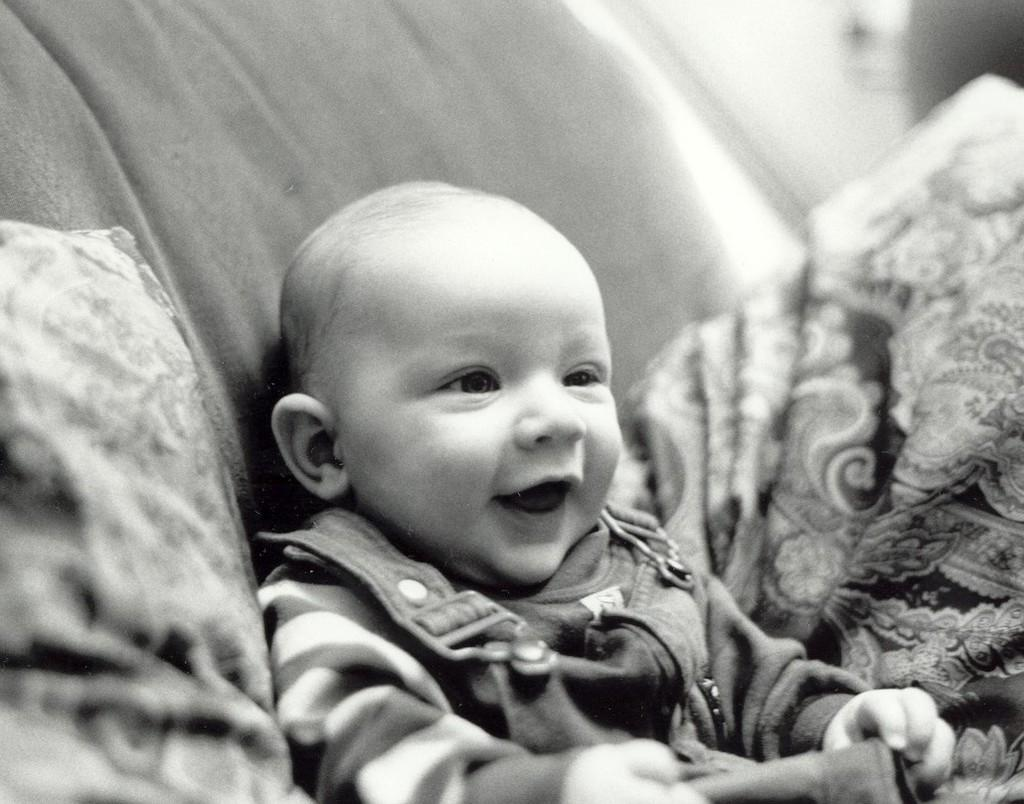What is the color scheme of the image? The image is black and white. Who or what is the main subject in the image? There is a kid in the image. Where is the kid located? The kid is on a sofa. What items can be seen on the sofa? There is a pillow and a bed sheet on the sofa. How would you describe the background of the image? The background of the image is blurry. What type of parcel is being delivered to the kid in the image? There is no parcel visible in the image. What kind of music is the band playing in the background of the image? There is no band or music present in the image. 